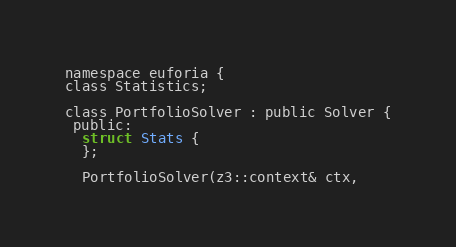<code> <loc_0><loc_0><loc_500><loc_500><_C_>namespace euforia {
class Statistics;

class PortfolioSolver : public Solver {
 public:
  struct Stats {
  };

  PortfolioSolver(z3::context& ctx,</code> 